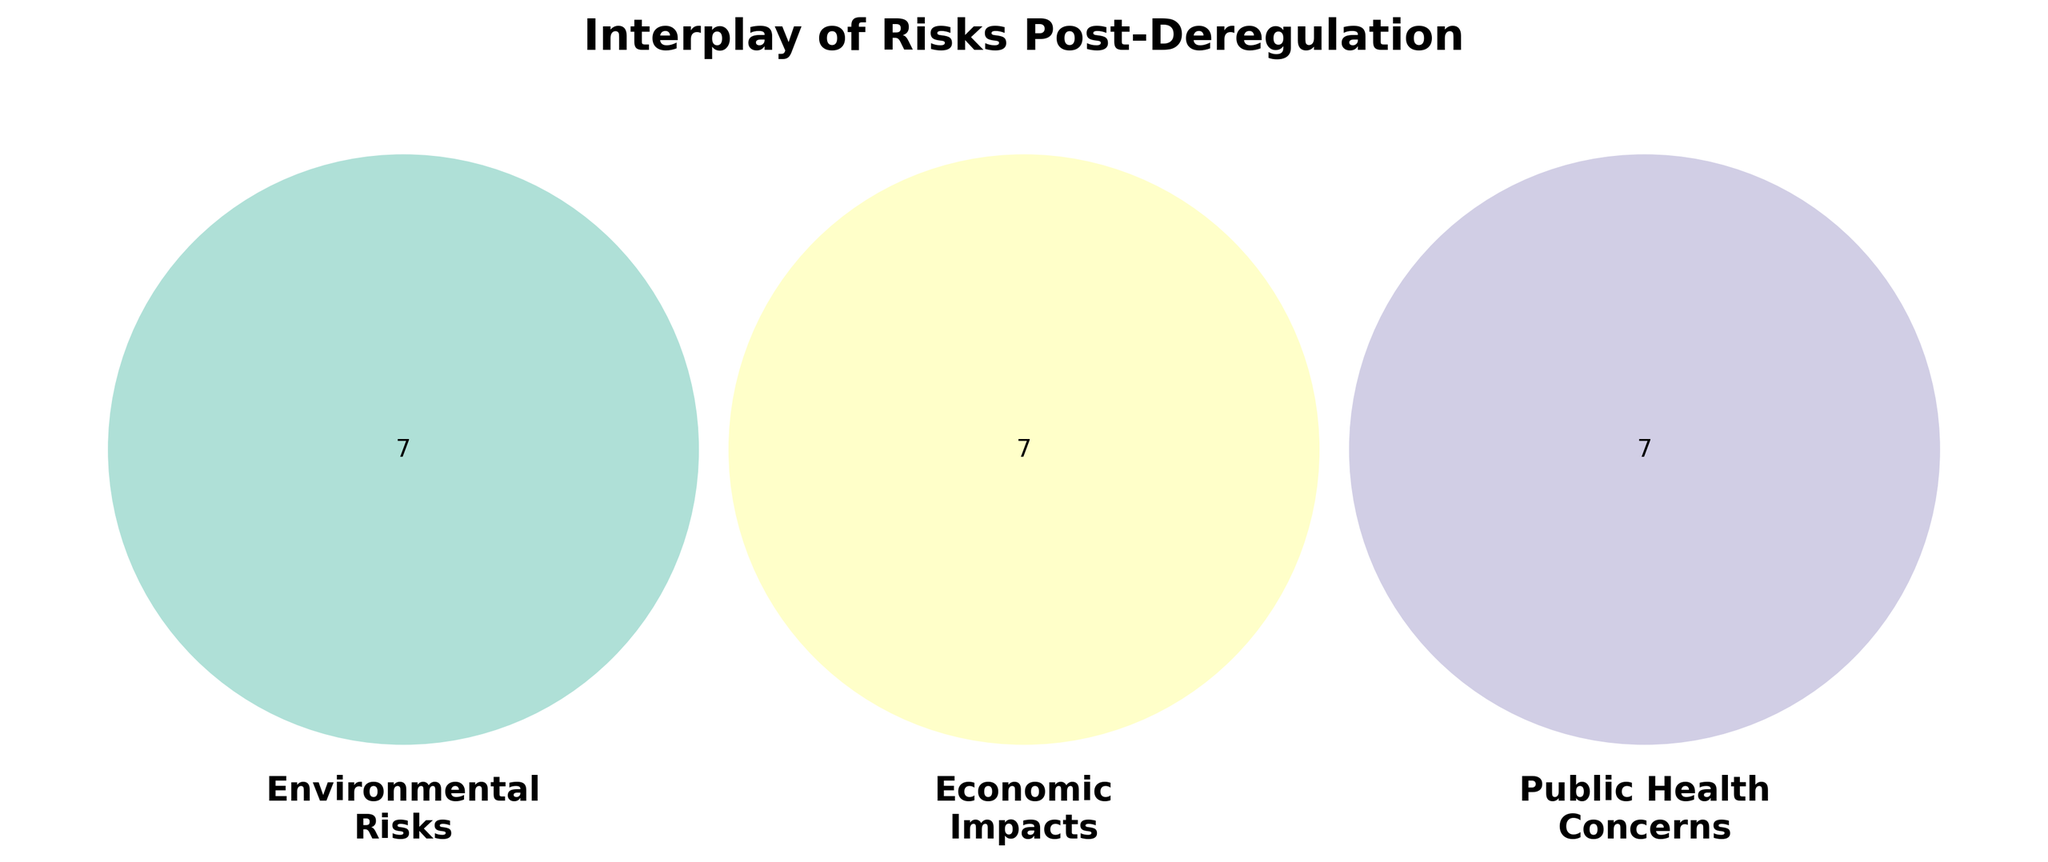How many categories of risks are displayed? The Venn diagram shows three intersecting circles representing the three categories of risks: Environmental Risks, Economic Impacts, and Public Health Concerns.
Answer: Three What is the main color used for Environmental Risks? The main color used for Environmental Risks is a shade of green. This can be identified by observing the color of the corresponding circle.
Answer: Green Which economic impact is linked to tourism revenue? By referring to the Economic Impacts section of the Venn diagram, we can see that Tourism Revenue is one of the listed impacts.
Answer: Tourism revenue How many elements are only in the Public Health Concerns circle? To determine this, observe the Public Health Concerns circle and count the elements that do not overlap with the other circles. These are Respiratory diseases, Cancer risks, Vector-borne illnesses, Food safety issues, Heat-related deaths, Antibiotic resistance, and Skin cancer rates.
Answer: Seven Which risk appears only in the Environmental Risks section and not in any other section? Observing the Environmental Risks circle, we identify the risks not overlapping with other sections: Deforestation, Soil erosion, Climate change, Biodiversity loss, and Ozone depletion.
Answer: Five What relation exists between Energy Costs and Environmental Risks? Energy Costs is listed under Economic Impacts, and by checking overlaps, we find it's not directly linked to Environmental Risks on this diagram.
Answer: No direct relation Which two risks overlap between all three categories? By examining the center of the Venn diagram where all three circles intersect, we find an overlap exists but it’s unused indicating there are no such risks shown.
Answer: None Are water contamination and respiratory diseases interconnected? Referring to their respective parts on the Venn diagram, Water contamination is under Environmental Risks, while Respiratory diseases are under Public Health Concerns, and they don’t intersect.
Answer: No Does the Venn diagram indicate any overlap between Job losses and Cancer risks? By looking at the circles, Job losses in Economic Impacts and Cancer risks in Public Health Concerns do not overlap.
Answer: No Identify one economic impact that overlaps with an environmental risk. Observe where the Environmental Risks and Economic Impacts circles intersect; for example, Real estate values overlap with Soil erosion, indicating a shared concern.
Answer: Real estate values 